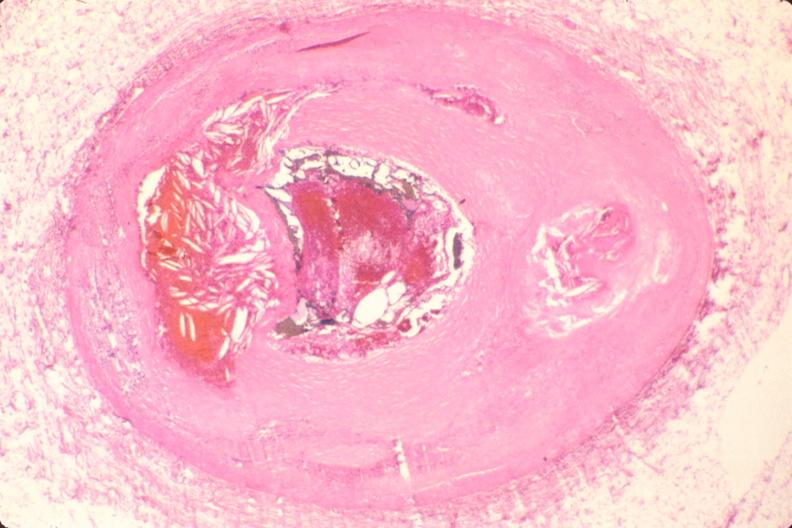s cardiovascular present?
Answer the question using a single word or phrase. Yes 